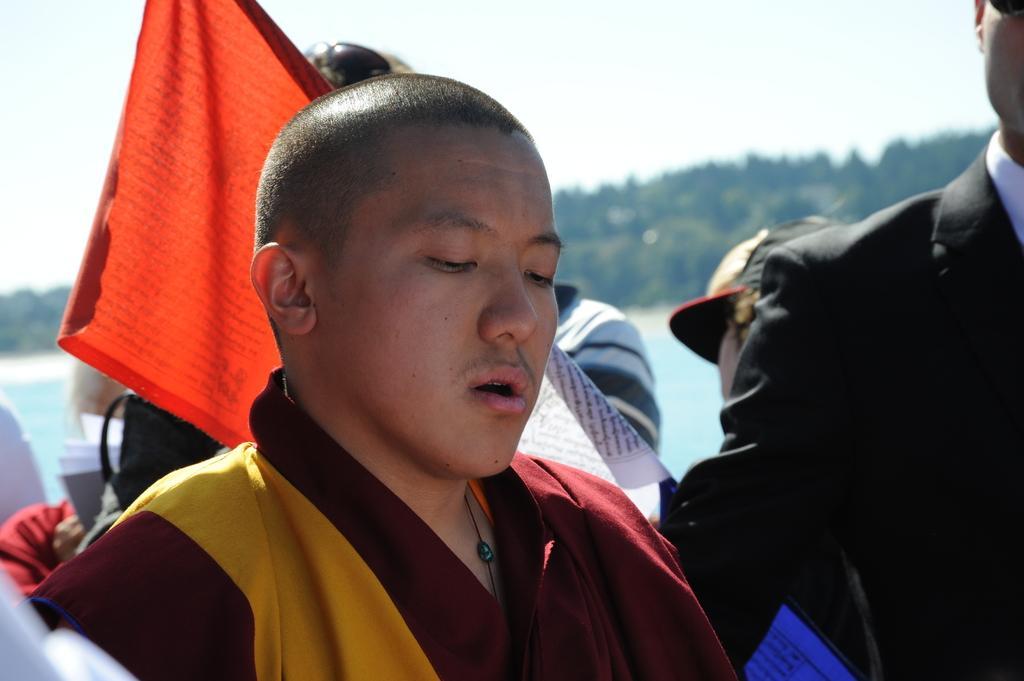Could you give a brief overview of what you see in this image? In the image we can see there are people standing and behind there is a red colour flag. 